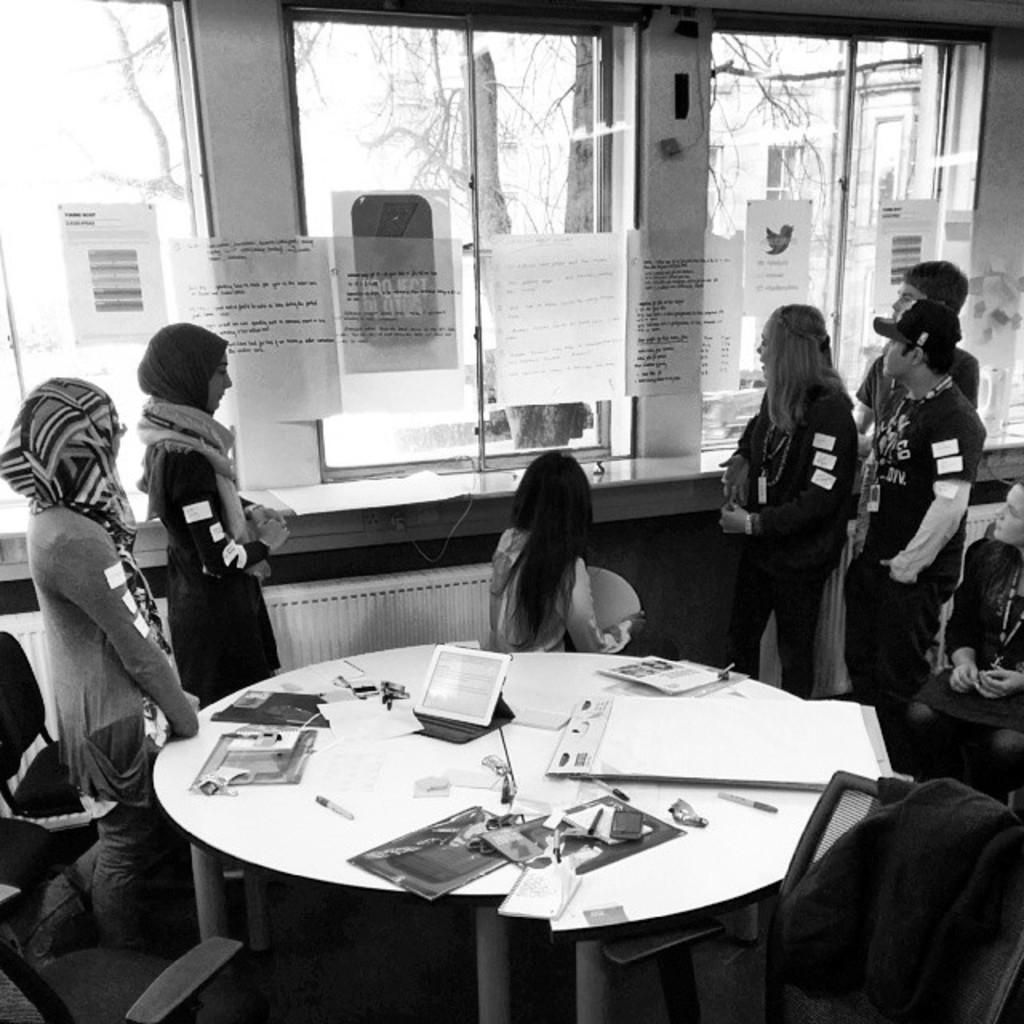Describe this image in one or two sentences. In the image we can see there are people who are standing and on the table there are papers, pen and ipad. 